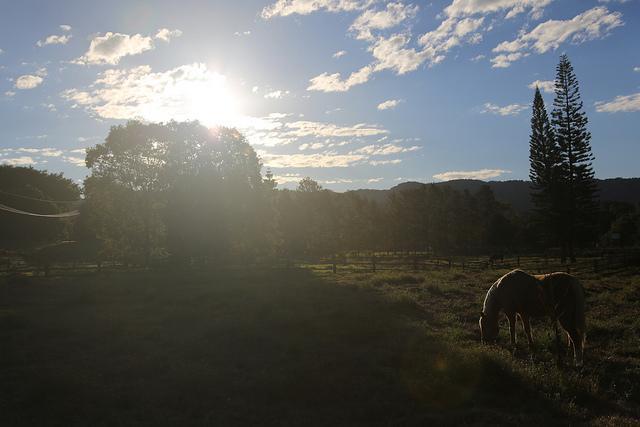How many of the train cars can you see someone sticking their head out of?
Give a very brief answer. 0. 